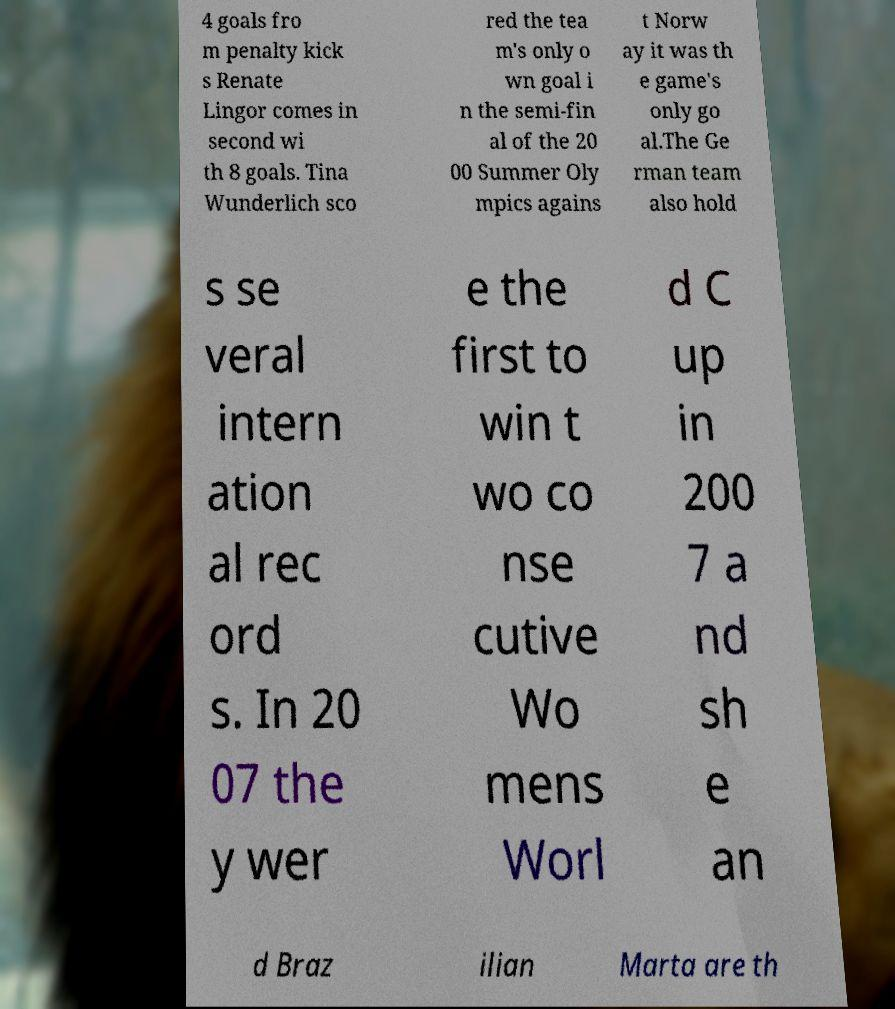Please identify and transcribe the text found in this image. 4 goals fro m penalty kick s Renate Lingor comes in second wi th 8 goals. Tina Wunderlich sco red the tea m's only o wn goal i n the semi-fin al of the 20 00 Summer Oly mpics agains t Norw ay it was th e game's only go al.The Ge rman team also hold s se veral intern ation al rec ord s. In 20 07 the y wer e the first to win t wo co nse cutive Wo mens Worl d C up in 200 7 a nd sh e an d Braz ilian Marta are th 